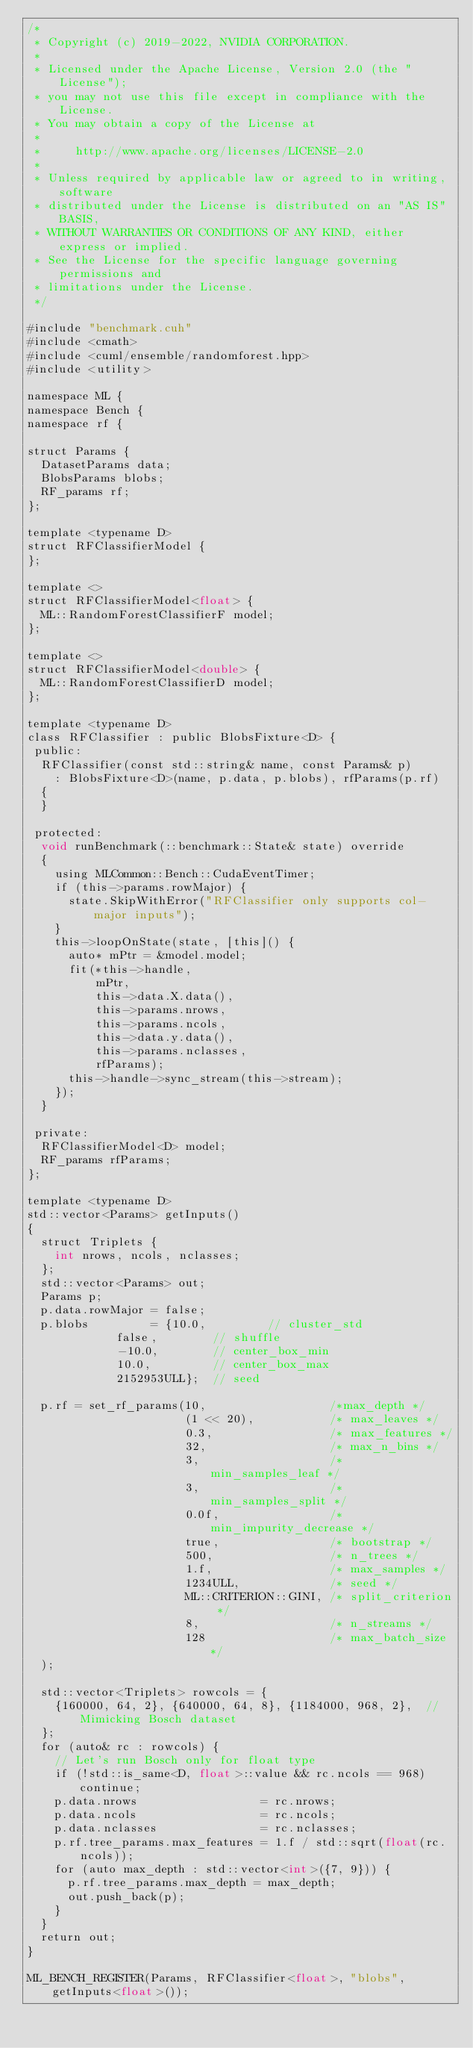Convert code to text. <code><loc_0><loc_0><loc_500><loc_500><_Cuda_>/*
 * Copyright (c) 2019-2022, NVIDIA CORPORATION.
 *
 * Licensed under the Apache License, Version 2.0 (the "License");
 * you may not use this file except in compliance with the License.
 * You may obtain a copy of the License at
 *
 *     http://www.apache.org/licenses/LICENSE-2.0
 *
 * Unless required by applicable law or agreed to in writing, software
 * distributed under the License is distributed on an "AS IS" BASIS,
 * WITHOUT WARRANTIES OR CONDITIONS OF ANY KIND, either express or implied.
 * See the License for the specific language governing permissions and
 * limitations under the License.
 */

#include "benchmark.cuh"
#include <cmath>
#include <cuml/ensemble/randomforest.hpp>
#include <utility>

namespace ML {
namespace Bench {
namespace rf {

struct Params {
  DatasetParams data;
  BlobsParams blobs;
  RF_params rf;
};

template <typename D>
struct RFClassifierModel {
};

template <>
struct RFClassifierModel<float> {
  ML::RandomForestClassifierF model;
};

template <>
struct RFClassifierModel<double> {
  ML::RandomForestClassifierD model;
};

template <typename D>
class RFClassifier : public BlobsFixture<D> {
 public:
  RFClassifier(const std::string& name, const Params& p)
    : BlobsFixture<D>(name, p.data, p.blobs), rfParams(p.rf)
  {
  }

 protected:
  void runBenchmark(::benchmark::State& state) override
  {
    using MLCommon::Bench::CudaEventTimer;
    if (this->params.rowMajor) {
      state.SkipWithError("RFClassifier only supports col-major inputs");
    }
    this->loopOnState(state, [this]() {
      auto* mPtr = &model.model;
      fit(*this->handle,
          mPtr,
          this->data.X.data(),
          this->params.nrows,
          this->params.ncols,
          this->data.y.data(),
          this->params.nclasses,
          rfParams);
      this->handle->sync_stream(this->stream);
    });
  }

 private:
  RFClassifierModel<D> model;
  RF_params rfParams;
};

template <typename D>
std::vector<Params> getInputs()
{
  struct Triplets {
    int nrows, ncols, nclasses;
  };
  std::vector<Params> out;
  Params p;
  p.data.rowMajor = false;
  p.blobs         = {10.0,         // cluster_std
             false,        // shuffle
             -10.0,        // center_box_min
             10.0,         // center_box_max
             2152953ULL};  // seed

  p.rf = set_rf_params(10,                  /*max_depth */
                       (1 << 20),           /* max_leaves */
                       0.3,                 /* max_features */
                       32,                  /* max_n_bins */
                       3,                   /* min_samples_leaf */
                       3,                   /* min_samples_split */
                       0.0f,                /* min_impurity_decrease */
                       true,                /* bootstrap */
                       500,                 /* n_trees */
                       1.f,                 /* max_samples */
                       1234ULL,             /* seed */
                       ML::CRITERION::GINI, /* split_criterion */
                       8,                   /* n_streams */
                       128                  /* max_batch_size */
  );

  std::vector<Triplets> rowcols = {
    {160000, 64, 2}, {640000, 64, 8}, {1184000, 968, 2},  // Mimicking Bosch dataset
  };
  for (auto& rc : rowcols) {
    // Let's run Bosch only for float type
    if (!std::is_same<D, float>::value && rc.ncols == 968) continue;
    p.data.nrows                  = rc.nrows;
    p.data.ncols                  = rc.ncols;
    p.data.nclasses               = rc.nclasses;
    p.rf.tree_params.max_features = 1.f / std::sqrt(float(rc.ncols));
    for (auto max_depth : std::vector<int>({7, 9})) {
      p.rf.tree_params.max_depth = max_depth;
      out.push_back(p);
    }
  }
  return out;
}

ML_BENCH_REGISTER(Params, RFClassifier<float>, "blobs", getInputs<float>());</code> 